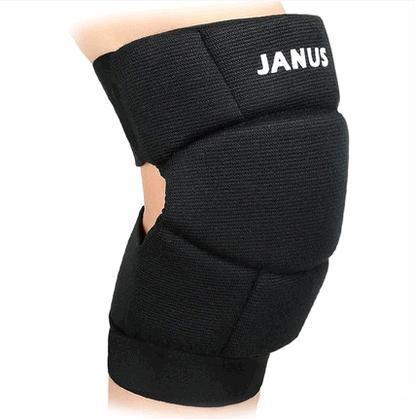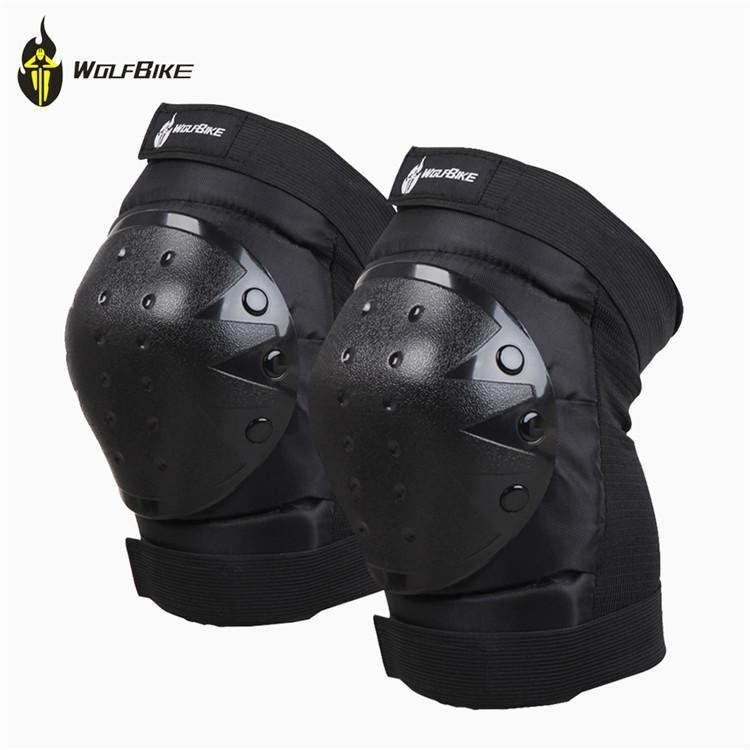The first image is the image on the left, the second image is the image on the right. Analyze the images presented: Is the assertion "There are three knee pads." valid? Answer yes or no. Yes. The first image is the image on the left, the second image is the image on the right. Examine the images to the left and right. Is the description "There are 3 knee braces in the images." accurate? Answer yes or no. Yes. 